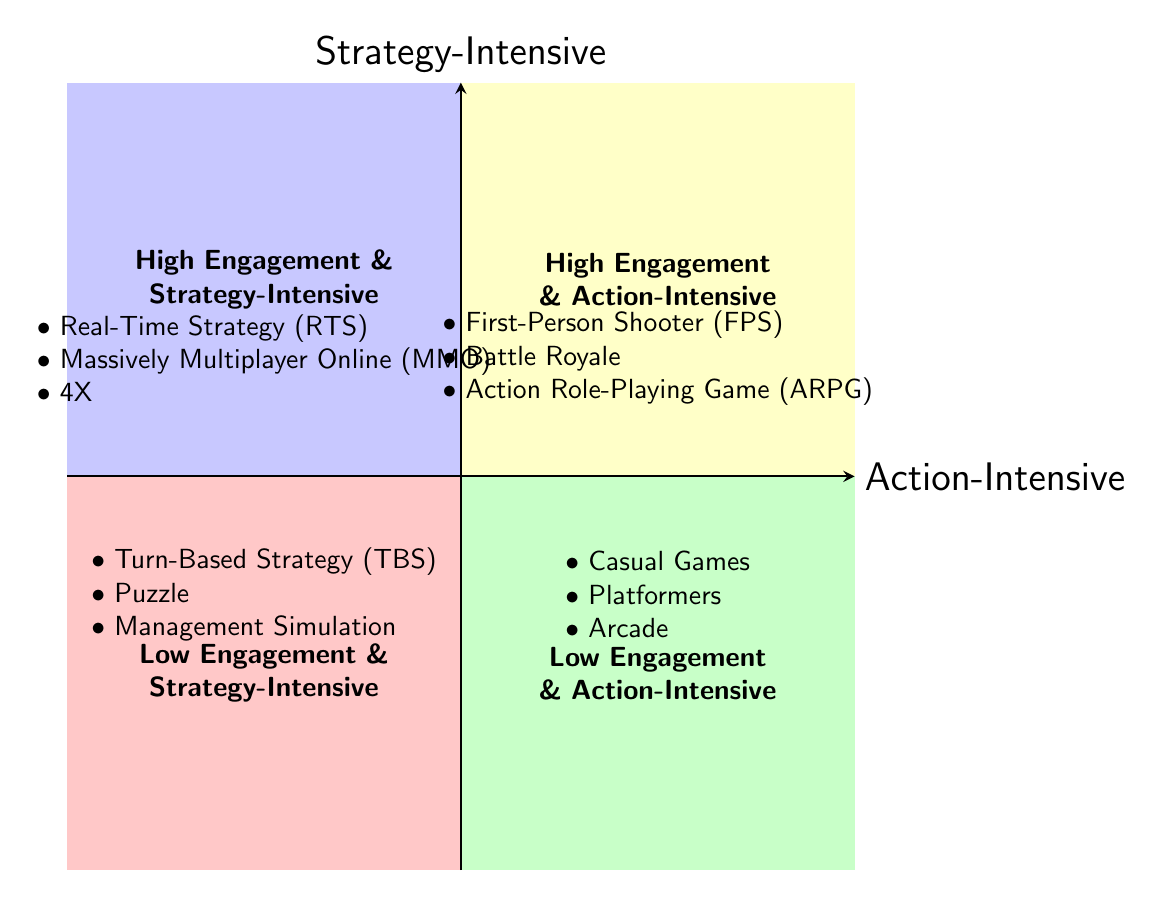What genres are listed in the High Engagement & Strategy-Intensive quadrant? The diagram indicates that the genres in this quadrant are Real-Time Strategy (RTS), Massively Multiplayer Online (MMO), and 4X. You can find these listed in the top-left section of the chart clearly designated for high engagement and strategy-intensive games.
Answer: Real-Time Strategy (RTS), Massively Multiplayer Online (MMO), 4X Which genre appears in both high engagement quadrants? By analyzing the diagram, I see that the First-Person Shooter (FPS) is included in the High Engagement & Action-Intensive quadrant, indicating its appeal. I compare this with other genres, confirming that it's not listed in the low engagement quadrants.
Answer: First-Person Shooter (FPS) How many genres are listed in the Low Engagement & Action-Intensive quadrant? The diagram details three genres within this quadrant: Casual Games, Platformers, and Arcade. So, by counting these entries, I determine the total amount present in that section.
Answer: 3 Are there any genres that fall under both strategy-intensive and high engagement categories? Recalling the definitions for each quadrant shown in the diagram, I identify Real-Time Strategy (RTS), Massively Multiplayer Online (MMO), and 4X as examples found strictly in the High Engagement & Strategy-Intensive quadrant. Since they don’t appear in other quadrants, these genres are an example of that overlap.
Answer: Yes, Real-Time Strategy (RTS), Massively Multiplayer Online (MMO), 4X What’s the relationship between Action-Intensive and Strategy-Intensive genres? The model organizes genres into two axes representing Action-Intensive at the horizontal axis and Strategy-Intensive at the vertical axis. By analyzing the chart, I see that genres can be categorized distinctly along these two styles, suggesting that games can emphasize different aspects of play.
Answer: Distinct categories, Action-Intensive and Strategy-Intensive genres Which quadrant contains Turn-Based Strategy? By looking at the diagram, Turn-Based Strategy (TBS) is clearly located in the Low Engagement & Strategy-Intensive quadrant as per its positioning, which indicates it does not engage the player as intensely as higher engagement genres.
Answer: Low Engagement & Strategy-Intensive How does player engagement change from high to low in action-intensive games? I review the quadrant chart and observe that as engagement decreases from the High Engagement & Action-Intensive quadrant (which includes FPS and Battle Royale), it transitions into the Low Engagement & Action-Intensive quadrant featuring genres like Casual Games and Platformers, indicating a clear distinction in diminishing player engagement.
Answer: Decreases, leading to Casual Games and Platformers What distinguishes High Engagement genres from Low Engagement genres? The distinction between High Engagement and Low Engagement genres is represented by the vertical axis. Each quadrant reflects the degree of player engagement, with high engagement involving genres that keep players engrossed (like RTS/MMO) and low engagement comprising more casual, less immersive types.
Answer: Degree of player engagement Which genre is categorized as both action-intensive and low engagement? Among the low engagement quadrant, I specifically look for action-intensive genres and find Casual Games as the sole representative in the Low Engagement & Action-Intensive quadrant, confirming it fits both criteria.
Answer: Casual Games 